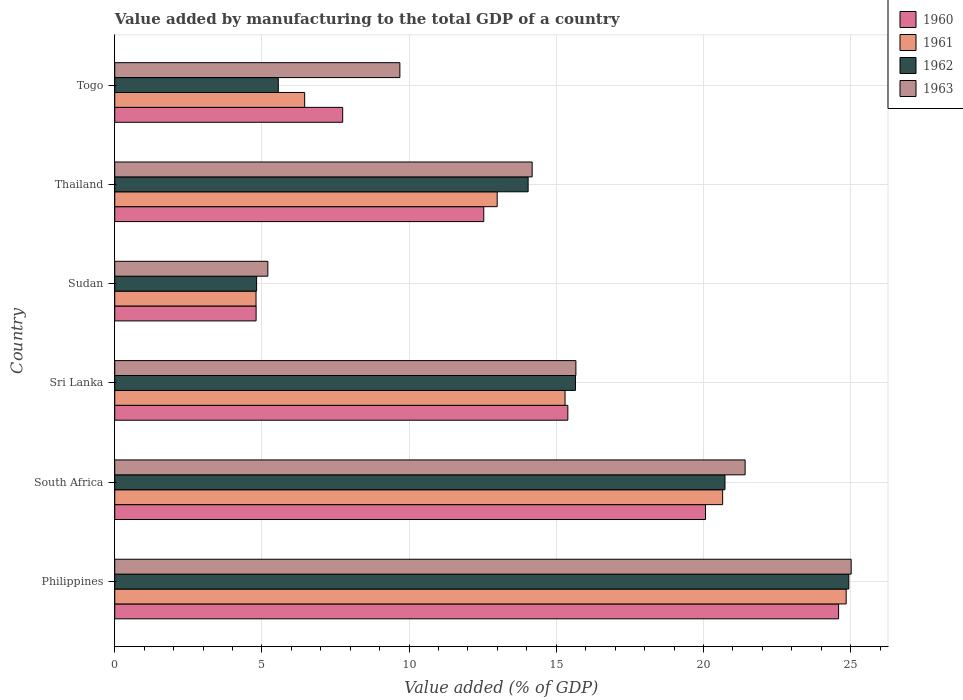How many groups of bars are there?
Provide a succinct answer. 6. How many bars are there on the 1st tick from the bottom?
Your response must be concise. 4. What is the label of the 1st group of bars from the top?
Keep it short and to the point. Togo. In how many cases, is the number of bars for a given country not equal to the number of legend labels?
Your answer should be very brief. 0. What is the value added by manufacturing to the total GDP in 1962 in Philippines?
Your answer should be compact. 24.94. Across all countries, what is the maximum value added by manufacturing to the total GDP in 1962?
Keep it short and to the point. 24.94. Across all countries, what is the minimum value added by manufacturing to the total GDP in 1963?
Ensure brevity in your answer.  5.2. In which country was the value added by manufacturing to the total GDP in 1963 maximum?
Offer a very short reply. Philippines. In which country was the value added by manufacturing to the total GDP in 1960 minimum?
Make the answer very short. Sudan. What is the total value added by manufacturing to the total GDP in 1960 in the graph?
Provide a succinct answer. 85.14. What is the difference between the value added by manufacturing to the total GDP in 1963 in Philippines and that in Sudan?
Your answer should be very brief. 19.82. What is the difference between the value added by manufacturing to the total GDP in 1962 in Togo and the value added by manufacturing to the total GDP in 1960 in Thailand?
Your response must be concise. -6.98. What is the average value added by manufacturing to the total GDP in 1961 per country?
Provide a short and direct response. 14.17. What is the difference between the value added by manufacturing to the total GDP in 1960 and value added by manufacturing to the total GDP in 1961 in South Africa?
Your answer should be compact. -0.58. What is the ratio of the value added by manufacturing to the total GDP in 1960 in Philippines to that in Sri Lanka?
Offer a very short reply. 1.6. What is the difference between the highest and the second highest value added by manufacturing to the total GDP in 1962?
Keep it short and to the point. 4.21. What is the difference between the highest and the lowest value added by manufacturing to the total GDP in 1963?
Make the answer very short. 19.82. Is the sum of the value added by manufacturing to the total GDP in 1960 in Philippines and Sudan greater than the maximum value added by manufacturing to the total GDP in 1962 across all countries?
Your answer should be very brief. Yes. What does the 1st bar from the top in Sri Lanka represents?
Provide a succinct answer. 1963. Is it the case that in every country, the sum of the value added by manufacturing to the total GDP in 1962 and value added by manufacturing to the total GDP in 1963 is greater than the value added by manufacturing to the total GDP in 1961?
Offer a terse response. Yes. How many bars are there?
Offer a terse response. 24. Are all the bars in the graph horizontal?
Provide a short and direct response. Yes. How many countries are there in the graph?
Provide a succinct answer. 6. Are the values on the major ticks of X-axis written in scientific E-notation?
Keep it short and to the point. No. Where does the legend appear in the graph?
Keep it short and to the point. Top right. How many legend labels are there?
Your answer should be compact. 4. What is the title of the graph?
Your answer should be compact. Value added by manufacturing to the total GDP of a country. Does "2013" appear as one of the legend labels in the graph?
Make the answer very short. No. What is the label or title of the X-axis?
Offer a terse response. Value added (% of GDP). What is the Value added (% of GDP) in 1960 in Philippines?
Your answer should be very brief. 24.59. What is the Value added (% of GDP) in 1961 in Philippines?
Offer a terse response. 24.85. What is the Value added (% of GDP) of 1962 in Philippines?
Provide a short and direct response. 24.94. What is the Value added (% of GDP) of 1963 in Philippines?
Provide a short and direct response. 25.02. What is the Value added (% of GDP) in 1960 in South Africa?
Offer a terse response. 20.07. What is the Value added (% of GDP) of 1961 in South Africa?
Offer a very short reply. 20.65. What is the Value added (% of GDP) in 1962 in South Africa?
Ensure brevity in your answer.  20.73. What is the Value added (% of GDP) in 1963 in South Africa?
Offer a terse response. 21.42. What is the Value added (% of GDP) of 1960 in Sri Lanka?
Give a very brief answer. 15.39. What is the Value added (% of GDP) in 1961 in Sri Lanka?
Your answer should be very brief. 15.3. What is the Value added (% of GDP) in 1962 in Sri Lanka?
Provide a succinct answer. 15.65. What is the Value added (% of GDP) in 1963 in Sri Lanka?
Provide a succinct answer. 15.67. What is the Value added (% of GDP) of 1960 in Sudan?
Provide a succinct answer. 4.8. What is the Value added (% of GDP) in 1961 in Sudan?
Give a very brief answer. 4.8. What is the Value added (% of GDP) of 1962 in Sudan?
Provide a succinct answer. 4.82. What is the Value added (% of GDP) in 1963 in Sudan?
Make the answer very short. 5.2. What is the Value added (% of GDP) of 1960 in Thailand?
Offer a terse response. 12.54. What is the Value added (% of GDP) in 1961 in Thailand?
Your answer should be very brief. 12.99. What is the Value added (% of GDP) of 1962 in Thailand?
Ensure brevity in your answer.  14.04. What is the Value added (% of GDP) in 1963 in Thailand?
Provide a short and direct response. 14.18. What is the Value added (% of GDP) of 1960 in Togo?
Offer a terse response. 7.74. What is the Value added (% of GDP) of 1961 in Togo?
Give a very brief answer. 6.45. What is the Value added (% of GDP) of 1962 in Togo?
Make the answer very short. 5.56. What is the Value added (% of GDP) of 1963 in Togo?
Offer a very short reply. 9.69. Across all countries, what is the maximum Value added (% of GDP) in 1960?
Provide a short and direct response. 24.59. Across all countries, what is the maximum Value added (% of GDP) in 1961?
Provide a short and direct response. 24.85. Across all countries, what is the maximum Value added (% of GDP) of 1962?
Ensure brevity in your answer.  24.94. Across all countries, what is the maximum Value added (% of GDP) of 1963?
Offer a very short reply. 25.02. Across all countries, what is the minimum Value added (% of GDP) of 1960?
Provide a succinct answer. 4.8. Across all countries, what is the minimum Value added (% of GDP) of 1961?
Offer a very short reply. 4.8. Across all countries, what is the minimum Value added (% of GDP) in 1962?
Provide a succinct answer. 4.82. Across all countries, what is the minimum Value added (% of GDP) in 1963?
Your response must be concise. 5.2. What is the total Value added (% of GDP) of 1960 in the graph?
Provide a succinct answer. 85.14. What is the total Value added (% of GDP) of 1961 in the graph?
Your answer should be compact. 85.04. What is the total Value added (% of GDP) in 1962 in the graph?
Your answer should be compact. 85.74. What is the total Value added (% of GDP) of 1963 in the graph?
Offer a very short reply. 91.17. What is the difference between the Value added (% of GDP) in 1960 in Philippines and that in South Africa?
Provide a short and direct response. 4.52. What is the difference between the Value added (% of GDP) of 1961 in Philippines and that in South Africa?
Provide a succinct answer. 4.2. What is the difference between the Value added (% of GDP) in 1962 in Philippines and that in South Africa?
Ensure brevity in your answer.  4.21. What is the difference between the Value added (% of GDP) of 1963 in Philippines and that in South Africa?
Your answer should be compact. 3.6. What is the difference between the Value added (% of GDP) in 1960 in Philippines and that in Sri Lanka?
Provide a succinct answer. 9.2. What is the difference between the Value added (% of GDP) of 1961 in Philippines and that in Sri Lanka?
Your answer should be compact. 9.55. What is the difference between the Value added (% of GDP) of 1962 in Philippines and that in Sri Lanka?
Keep it short and to the point. 9.29. What is the difference between the Value added (% of GDP) of 1963 in Philippines and that in Sri Lanka?
Offer a terse response. 9.35. What is the difference between the Value added (% of GDP) of 1960 in Philippines and that in Sudan?
Your answer should be very brief. 19.79. What is the difference between the Value added (% of GDP) of 1961 in Philippines and that in Sudan?
Make the answer very short. 20.05. What is the difference between the Value added (% of GDP) in 1962 in Philippines and that in Sudan?
Make the answer very short. 20.12. What is the difference between the Value added (% of GDP) in 1963 in Philippines and that in Sudan?
Provide a short and direct response. 19.82. What is the difference between the Value added (% of GDP) of 1960 in Philippines and that in Thailand?
Keep it short and to the point. 12.05. What is the difference between the Value added (% of GDP) in 1961 in Philippines and that in Thailand?
Your answer should be very brief. 11.86. What is the difference between the Value added (% of GDP) in 1962 in Philippines and that in Thailand?
Offer a terse response. 10.9. What is the difference between the Value added (% of GDP) in 1963 in Philippines and that in Thailand?
Your response must be concise. 10.84. What is the difference between the Value added (% of GDP) of 1960 in Philippines and that in Togo?
Offer a terse response. 16.85. What is the difference between the Value added (% of GDP) of 1961 in Philippines and that in Togo?
Ensure brevity in your answer.  18.4. What is the difference between the Value added (% of GDP) of 1962 in Philippines and that in Togo?
Make the answer very short. 19.38. What is the difference between the Value added (% of GDP) in 1963 in Philippines and that in Togo?
Make the answer very short. 15.33. What is the difference between the Value added (% of GDP) of 1960 in South Africa and that in Sri Lanka?
Your response must be concise. 4.68. What is the difference between the Value added (% of GDP) of 1961 in South Africa and that in Sri Lanka?
Offer a terse response. 5.36. What is the difference between the Value added (% of GDP) in 1962 in South Africa and that in Sri Lanka?
Offer a terse response. 5.08. What is the difference between the Value added (% of GDP) of 1963 in South Africa and that in Sri Lanka?
Offer a terse response. 5.75. What is the difference between the Value added (% of GDP) in 1960 in South Africa and that in Sudan?
Make the answer very short. 15.27. What is the difference between the Value added (% of GDP) of 1961 in South Africa and that in Sudan?
Your answer should be very brief. 15.85. What is the difference between the Value added (% of GDP) of 1962 in South Africa and that in Sudan?
Provide a short and direct response. 15.91. What is the difference between the Value added (% of GDP) in 1963 in South Africa and that in Sudan?
Provide a short and direct response. 16.22. What is the difference between the Value added (% of GDP) of 1960 in South Africa and that in Thailand?
Provide a short and direct response. 7.53. What is the difference between the Value added (% of GDP) of 1961 in South Africa and that in Thailand?
Offer a very short reply. 7.66. What is the difference between the Value added (% of GDP) of 1962 in South Africa and that in Thailand?
Keep it short and to the point. 6.69. What is the difference between the Value added (% of GDP) of 1963 in South Africa and that in Thailand?
Ensure brevity in your answer.  7.24. What is the difference between the Value added (% of GDP) of 1960 in South Africa and that in Togo?
Offer a terse response. 12.33. What is the difference between the Value added (% of GDP) in 1961 in South Africa and that in Togo?
Offer a very short reply. 14.2. What is the difference between the Value added (% of GDP) of 1962 in South Africa and that in Togo?
Provide a short and direct response. 15.18. What is the difference between the Value added (% of GDP) in 1963 in South Africa and that in Togo?
Provide a short and direct response. 11.73. What is the difference between the Value added (% of GDP) of 1960 in Sri Lanka and that in Sudan?
Make the answer very short. 10.59. What is the difference between the Value added (% of GDP) in 1961 in Sri Lanka and that in Sudan?
Make the answer very short. 10.5. What is the difference between the Value added (% of GDP) of 1962 in Sri Lanka and that in Sudan?
Give a very brief answer. 10.83. What is the difference between the Value added (% of GDP) in 1963 in Sri Lanka and that in Sudan?
Your answer should be very brief. 10.47. What is the difference between the Value added (% of GDP) of 1960 in Sri Lanka and that in Thailand?
Provide a short and direct response. 2.86. What is the difference between the Value added (% of GDP) in 1961 in Sri Lanka and that in Thailand?
Your response must be concise. 2.3. What is the difference between the Value added (% of GDP) of 1962 in Sri Lanka and that in Thailand?
Keep it short and to the point. 1.61. What is the difference between the Value added (% of GDP) in 1963 in Sri Lanka and that in Thailand?
Provide a short and direct response. 1.49. What is the difference between the Value added (% of GDP) in 1960 in Sri Lanka and that in Togo?
Offer a very short reply. 7.65. What is the difference between the Value added (% of GDP) of 1961 in Sri Lanka and that in Togo?
Offer a terse response. 8.85. What is the difference between the Value added (% of GDP) of 1962 in Sri Lanka and that in Togo?
Provide a succinct answer. 10.1. What is the difference between the Value added (% of GDP) in 1963 in Sri Lanka and that in Togo?
Ensure brevity in your answer.  5.98. What is the difference between the Value added (% of GDP) of 1960 in Sudan and that in Thailand?
Make the answer very short. -7.73. What is the difference between the Value added (% of GDP) in 1961 in Sudan and that in Thailand?
Ensure brevity in your answer.  -8.19. What is the difference between the Value added (% of GDP) of 1962 in Sudan and that in Thailand?
Offer a terse response. -9.23. What is the difference between the Value added (% of GDP) in 1963 in Sudan and that in Thailand?
Offer a terse response. -8.98. What is the difference between the Value added (% of GDP) in 1960 in Sudan and that in Togo?
Provide a succinct answer. -2.94. What is the difference between the Value added (% of GDP) of 1961 in Sudan and that in Togo?
Your answer should be very brief. -1.65. What is the difference between the Value added (% of GDP) in 1962 in Sudan and that in Togo?
Your answer should be very brief. -0.74. What is the difference between the Value added (% of GDP) in 1963 in Sudan and that in Togo?
Provide a succinct answer. -4.49. What is the difference between the Value added (% of GDP) of 1960 in Thailand and that in Togo?
Your answer should be very brief. 4.79. What is the difference between the Value added (% of GDP) of 1961 in Thailand and that in Togo?
Offer a terse response. 6.54. What is the difference between the Value added (% of GDP) in 1962 in Thailand and that in Togo?
Offer a very short reply. 8.49. What is the difference between the Value added (% of GDP) of 1963 in Thailand and that in Togo?
Offer a very short reply. 4.49. What is the difference between the Value added (% of GDP) in 1960 in Philippines and the Value added (% of GDP) in 1961 in South Africa?
Your response must be concise. 3.94. What is the difference between the Value added (% of GDP) of 1960 in Philippines and the Value added (% of GDP) of 1962 in South Africa?
Ensure brevity in your answer.  3.86. What is the difference between the Value added (% of GDP) of 1960 in Philippines and the Value added (% of GDP) of 1963 in South Africa?
Offer a terse response. 3.18. What is the difference between the Value added (% of GDP) in 1961 in Philippines and the Value added (% of GDP) in 1962 in South Africa?
Offer a terse response. 4.12. What is the difference between the Value added (% of GDP) of 1961 in Philippines and the Value added (% of GDP) of 1963 in South Africa?
Provide a short and direct response. 3.43. What is the difference between the Value added (% of GDP) of 1962 in Philippines and the Value added (% of GDP) of 1963 in South Africa?
Your response must be concise. 3.52. What is the difference between the Value added (% of GDP) in 1960 in Philippines and the Value added (% of GDP) in 1961 in Sri Lanka?
Ensure brevity in your answer.  9.29. What is the difference between the Value added (% of GDP) of 1960 in Philippines and the Value added (% of GDP) of 1962 in Sri Lanka?
Your response must be concise. 8.94. What is the difference between the Value added (% of GDP) in 1960 in Philippines and the Value added (% of GDP) in 1963 in Sri Lanka?
Offer a very short reply. 8.93. What is the difference between the Value added (% of GDP) in 1961 in Philippines and the Value added (% of GDP) in 1962 in Sri Lanka?
Provide a succinct answer. 9.2. What is the difference between the Value added (% of GDP) of 1961 in Philippines and the Value added (% of GDP) of 1963 in Sri Lanka?
Offer a terse response. 9.18. What is the difference between the Value added (% of GDP) of 1962 in Philippines and the Value added (% of GDP) of 1963 in Sri Lanka?
Ensure brevity in your answer.  9.27. What is the difference between the Value added (% of GDP) in 1960 in Philippines and the Value added (% of GDP) in 1961 in Sudan?
Make the answer very short. 19.79. What is the difference between the Value added (% of GDP) in 1960 in Philippines and the Value added (% of GDP) in 1962 in Sudan?
Offer a very short reply. 19.77. What is the difference between the Value added (% of GDP) of 1960 in Philippines and the Value added (% of GDP) of 1963 in Sudan?
Give a very brief answer. 19.39. What is the difference between the Value added (% of GDP) in 1961 in Philippines and the Value added (% of GDP) in 1962 in Sudan?
Ensure brevity in your answer.  20.03. What is the difference between the Value added (% of GDP) of 1961 in Philippines and the Value added (% of GDP) of 1963 in Sudan?
Your answer should be compact. 19.65. What is the difference between the Value added (% of GDP) of 1962 in Philippines and the Value added (% of GDP) of 1963 in Sudan?
Keep it short and to the point. 19.74. What is the difference between the Value added (% of GDP) in 1960 in Philippines and the Value added (% of GDP) in 1961 in Thailand?
Offer a terse response. 11.6. What is the difference between the Value added (% of GDP) in 1960 in Philippines and the Value added (% of GDP) in 1962 in Thailand?
Ensure brevity in your answer.  10.55. What is the difference between the Value added (% of GDP) of 1960 in Philippines and the Value added (% of GDP) of 1963 in Thailand?
Make the answer very short. 10.41. What is the difference between the Value added (% of GDP) in 1961 in Philippines and the Value added (% of GDP) in 1962 in Thailand?
Give a very brief answer. 10.81. What is the difference between the Value added (% of GDP) in 1961 in Philippines and the Value added (% of GDP) in 1963 in Thailand?
Your answer should be compact. 10.67. What is the difference between the Value added (% of GDP) in 1962 in Philippines and the Value added (% of GDP) in 1963 in Thailand?
Offer a very short reply. 10.76. What is the difference between the Value added (% of GDP) in 1960 in Philippines and the Value added (% of GDP) in 1961 in Togo?
Your answer should be compact. 18.14. What is the difference between the Value added (% of GDP) in 1960 in Philippines and the Value added (% of GDP) in 1962 in Togo?
Provide a short and direct response. 19.04. What is the difference between the Value added (% of GDP) of 1960 in Philippines and the Value added (% of GDP) of 1963 in Togo?
Provide a short and direct response. 14.91. What is the difference between the Value added (% of GDP) of 1961 in Philippines and the Value added (% of GDP) of 1962 in Togo?
Make the answer very short. 19.29. What is the difference between the Value added (% of GDP) in 1961 in Philippines and the Value added (% of GDP) in 1963 in Togo?
Give a very brief answer. 15.16. What is the difference between the Value added (% of GDP) of 1962 in Philippines and the Value added (% of GDP) of 1963 in Togo?
Offer a very short reply. 15.25. What is the difference between the Value added (% of GDP) in 1960 in South Africa and the Value added (% of GDP) in 1961 in Sri Lanka?
Your answer should be compact. 4.77. What is the difference between the Value added (% of GDP) of 1960 in South Africa and the Value added (% of GDP) of 1962 in Sri Lanka?
Offer a very short reply. 4.42. What is the difference between the Value added (% of GDP) of 1960 in South Africa and the Value added (% of GDP) of 1963 in Sri Lanka?
Give a very brief answer. 4.4. What is the difference between the Value added (% of GDP) in 1961 in South Africa and the Value added (% of GDP) in 1962 in Sri Lanka?
Make the answer very short. 5. What is the difference between the Value added (% of GDP) of 1961 in South Africa and the Value added (% of GDP) of 1963 in Sri Lanka?
Offer a terse response. 4.99. What is the difference between the Value added (% of GDP) of 1962 in South Africa and the Value added (% of GDP) of 1963 in Sri Lanka?
Your answer should be very brief. 5.07. What is the difference between the Value added (% of GDP) in 1960 in South Africa and the Value added (% of GDP) in 1961 in Sudan?
Give a very brief answer. 15.27. What is the difference between the Value added (% of GDP) in 1960 in South Africa and the Value added (% of GDP) in 1962 in Sudan?
Keep it short and to the point. 15.25. What is the difference between the Value added (% of GDP) of 1960 in South Africa and the Value added (% of GDP) of 1963 in Sudan?
Your answer should be very brief. 14.87. What is the difference between the Value added (% of GDP) in 1961 in South Africa and the Value added (% of GDP) in 1962 in Sudan?
Provide a succinct answer. 15.83. What is the difference between the Value added (% of GDP) of 1961 in South Africa and the Value added (% of GDP) of 1963 in Sudan?
Provide a short and direct response. 15.45. What is the difference between the Value added (% of GDP) in 1962 in South Africa and the Value added (% of GDP) in 1963 in Sudan?
Provide a succinct answer. 15.53. What is the difference between the Value added (% of GDP) in 1960 in South Africa and the Value added (% of GDP) in 1961 in Thailand?
Ensure brevity in your answer.  7.08. What is the difference between the Value added (% of GDP) in 1960 in South Africa and the Value added (% of GDP) in 1962 in Thailand?
Provide a short and direct response. 6.03. What is the difference between the Value added (% of GDP) in 1960 in South Africa and the Value added (% of GDP) in 1963 in Thailand?
Ensure brevity in your answer.  5.89. What is the difference between the Value added (% of GDP) in 1961 in South Africa and the Value added (% of GDP) in 1962 in Thailand?
Your response must be concise. 6.61. What is the difference between the Value added (% of GDP) in 1961 in South Africa and the Value added (% of GDP) in 1963 in Thailand?
Offer a terse response. 6.47. What is the difference between the Value added (% of GDP) in 1962 in South Africa and the Value added (% of GDP) in 1963 in Thailand?
Ensure brevity in your answer.  6.55. What is the difference between the Value added (% of GDP) of 1960 in South Africa and the Value added (% of GDP) of 1961 in Togo?
Offer a very short reply. 13.62. What is the difference between the Value added (% of GDP) in 1960 in South Africa and the Value added (% of GDP) in 1962 in Togo?
Your answer should be compact. 14.51. What is the difference between the Value added (% of GDP) in 1960 in South Africa and the Value added (% of GDP) in 1963 in Togo?
Provide a short and direct response. 10.38. What is the difference between the Value added (% of GDP) of 1961 in South Africa and the Value added (% of GDP) of 1962 in Togo?
Offer a terse response. 15.1. What is the difference between the Value added (% of GDP) of 1961 in South Africa and the Value added (% of GDP) of 1963 in Togo?
Make the answer very short. 10.97. What is the difference between the Value added (% of GDP) in 1962 in South Africa and the Value added (% of GDP) in 1963 in Togo?
Offer a terse response. 11.05. What is the difference between the Value added (% of GDP) in 1960 in Sri Lanka and the Value added (% of GDP) in 1961 in Sudan?
Keep it short and to the point. 10.59. What is the difference between the Value added (% of GDP) in 1960 in Sri Lanka and the Value added (% of GDP) in 1962 in Sudan?
Provide a short and direct response. 10.57. What is the difference between the Value added (% of GDP) of 1960 in Sri Lanka and the Value added (% of GDP) of 1963 in Sudan?
Your answer should be compact. 10.19. What is the difference between the Value added (% of GDP) in 1961 in Sri Lanka and the Value added (% of GDP) in 1962 in Sudan?
Provide a short and direct response. 10.48. What is the difference between the Value added (% of GDP) in 1961 in Sri Lanka and the Value added (% of GDP) in 1963 in Sudan?
Provide a short and direct response. 10.1. What is the difference between the Value added (% of GDP) of 1962 in Sri Lanka and the Value added (% of GDP) of 1963 in Sudan?
Provide a short and direct response. 10.45. What is the difference between the Value added (% of GDP) in 1960 in Sri Lanka and the Value added (% of GDP) in 1961 in Thailand?
Your answer should be compact. 2.4. What is the difference between the Value added (% of GDP) in 1960 in Sri Lanka and the Value added (% of GDP) in 1962 in Thailand?
Ensure brevity in your answer.  1.35. What is the difference between the Value added (% of GDP) of 1960 in Sri Lanka and the Value added (% of GDP) of 1963 in Thailand?
Ensure brevity in your answer.  1.21. What is the difference between the Value added (% of GDP) of 1961 in Sri Lanka and the Value added (% of GDP) of 1962 in Thailand?
Give a very brief answer. 1.25. What is the difference between the Value added (% of GDP) of 1961 in Sri Lanka and the Value added (% of GDP) of 1963 in Thailand?
Your response must be concise. 1.12. What is the difference between the Value added (% of GDP) of 1962 in Sri Lanka and the Value added (% of GDP) of 1963 in Thailand?
Provide a succinct answer. 1.47. What is the difference between the Value added (% of GDP) in 1960 in Sri Lanka and the Value added (% of GDP) in 1961 in Togo?
Your response must be concise. 8.94. What is the difference between the Value added (% of GDP) of 1960 in Sri Lanka and the Value added (% of GDP) of 1962 in Togo?
Your response must be concise. 9.84. What is the difference between the Value added (% of GDP) in 1960 in Sri Lanka and the Value added (% of GDP) in 1963 in Togo?
Your answer should be very brief. 5.71. What is the difference between the Value added (% of GDP) in 1961 in Sri Lanka and the Value added (% of GDP) in 1962 in Togo?
Your response must be concise. 9.74. What is the difference between the Value added (% of GDP) in 1961 in Sri Lanka and the Value added (% of GDP) in 1963 in Togo?
Your response must be concise. 5.61. What is the difference between the Value added (% of GDP) in 1962 in Sri Lanka and the Value added (% of GDP) in 1963 in Togo?
Keep it short and to the point. 5.97. What is the difference between the Value added (% of GDP) of 1960 in Sudan and the Value added (% of GDP) of 1961 in Thailand?
Offer a very short reply. -8.19. What is the difference between the Value added (% of GDP) in 1960 in Sudan and the Value added (% of GDP) in 1962 in Thailand?
Keep it short and to the point. -9.24. What is the difference between the Value added (% of GDP) of 1960 in Sudan and the Value added (% of GDP) of 1963 in Thailand?
Your answer should be compact. -9.38. What is the difference between the Value added (% of GDP) of 1961 in Sudan and the Value added (% of GDP) of 1962 in Thailand?
Keep it short and to the point. -9.24. What is the difference between the Value added (% of GDP) of 1961 in Sudan and the Value added (% of GDP) of 1963 in Thailand?
Provide a succinct answer. -9.38. What is the difference between the Value added (% of GDP) of 1962 in Sudan and the Value added (% of GDP) of 1963 in Thailand?
Keep it short and to the point. -9.36. What is the difference between the Value added (% of GDP) of 1960 in Sudan and the Value added (% of GDP) of 1961 in Togo?
Offer a very short reply. -1.65. What is the difference between the Value added (% of GDP) in 1960 in Sudan and the Value added (% of GDP) in 1962 in Togo?
Keep it short and to the point. -0.75. What is the difference between the Value added (% of GDP) of 1960 in Sudan and the Value added (% of GDP) of 1963 in Togo?
Provide a short and direct response. -4.88. What is the difference between the Value added (% of GDP) of 1961 in Sudan and the Value added (% of GDP) of 1962 in Togo?
Provide a succinct answer. -0.76. What is the difference between the Value added (% of GDP) of 1961 in Sudan and the Value added (% of GDP) of 1963 in Togo?
Make the answer very short. -4.89. What is the difference between the Value added (% of GDP) of 1962 in Sudan and the Value added (% of GDP) of 1963 in Togo?
Your response must be concise. -4.87. What is the difference between the Value added (% of GDP) of 1960 in Thailand and the Value added (% of GDP) of 1961 in Togo?
Offer a very short reply. 6.09. What is the difference between the Value added (% of GDP) in 1960 in Thailand and the Value added (% of GDP) in 1962 in Togo?
Offer a terse response. 6.98. What is the difference between the Value added (% of GDP) of 1960 in Thailand and the Value added (% of GDP) of 1963 in Togo?
Your answer should be compact. 2.85. What is the difference between the Value added (% of GDP) in 1961 in Thailand and the Value added (% of GDP) in 1962 in Togo?
Provide a short and direct response. 7.44. What is the difference between the Value added (% of GDP) of 1961 in Thailand and the Value added (% of GDP) of 1963 in Togo?
Offer a terse response. 3.31. What is the difference between the Value added (% of GDP) of 1962 in Thailand and the Value added (% of GDP) of 1963 in Togo?
Give a very brief answer. 4.36. What is the average Value added (% of GDP) of 1960 per country?
Give a very brief answer. 14.19. What is the average Value added (% of GDP) of 1961 per country?
Offer a very short reply. 14.17. What is the average Value added (% of GDP) in 1962 per country?
Offer a terse response. 14.29. What is the average Value added (% of GDP) of 1963 per country?
Offer a terse response. 15.2. What is the difference between the Value added (% of GDP) of 1960 and Value added (% of GDP) of 1961 in Philippines?
Your response must be concise. -0.26. What is the difference between the Value added (% of GDP) of 1960 and Value added (% of GDP) of 1962 in Philippines?
Your answer should be compact. -0.35. What is the difference between the Value added (% of GDP) in 1960 and Value added (% of GDP) in 1963 in Philippines?
Keep it short and to the point. -0.43. What is the difference between the Value added (% of GDP) of 1961 and Value added (% of GDP) of 1962 in Philippines?
Offer a terse response. -0.09. What is the difference between the Value added (% of GDP) of 1961 and Value added (% of GDP) of 1963 in Philippines?
Your answer should be very brief. -0.17. What is the difference between the Value added (% of GDP) of 1962 and Value added (% of GDP) of 1963 in Philippines?
Your answer should be very brief. -0.08. What is the difference between the Value added (% of GDP) in 1960 and Value added (% of GDP) in 1961 in South Africa?
Provide a short and direct response. -0.58. What is the difference between the Value added (% of GDP) of 1960 and Value added (% of GDP) of 1962 in South Africa?
Your answer should be compact. -0.66. What is the difference between the Value added (% of GDP) of 1960 and Value added (% of GDP) of 1963 in South Africa?
Offer a terse response. -1.35. What is the difference between the Value added (% of GDP) of 1961 and Value added (% of GDP) of 1962 in South Africa?
Make the answer very short. -0.08. What is the difference between the Value added (% of GDP) in 1961 and Value added (% of GDP) in 1963 in South Africa?
Ensure brevity in your answer.  -0.76. What is the difference between the Value added (% of GDP) in 1962 and Value added (% of GDP) in 1963 in South Africa?
Offer a very short reply. -0.68. What is the difference between the Value added (% of GDP) of 1960 and Value added (% of GDP) of 1961 in Sri Lanka?
Your response must be concise. 0.1. What is the difference between the Value added (% of GDP) in 1960 and Value added (% of GDP) in 1962 in Sri Lanka?
Your answer should be compact. -0.26. What is the difference between the Value added (% of GDP) of 1960 and Value added (% of GDP) of 1963 in Sri Lanka?
Provide a succinct answer. -0.27. What is the difference between the Value added (% of GDP) of 1961 and Value added (% of GDP) of 1962 in Sri Lanka?
Your response must be concise. -0.35. What is the difference between the Value added (% of GDP) in 1961 and Value added (% of GDP) in 1963 in Sri Lanka?
Offer a terse response. -0.37. What is the difference between the Value added (% of GDP) in 1962 and Value added (% of GDP) in 1963 in Sri Lanka?
Provide a succinct answer. -0.01. What is the difference between the Value added (% of GDP) in 1960 and Value added (% of GDP) in 1961 in Sudan?
Offer a terse response. 0. What is the difference between the Value added (% of GDP) in 1960 and Value added (% of GDP) in 1962 in Sudan?
Ensure brevity in your answer.  -0.02. What is the difference between the Value added (% of GDP) in 1960 and Value added (% of GDP) in 1963 in Sudan?
Give a very brief answer. -0.4. What is the difference between the Value added (% of GDP) in 1961 and Value added (% of GDP) in 1962 in Sudan?
Your response must be concise. -0.02. What is the difference between the Value added (% of GDP) in 1961 and Value added (% of GDP) in 1963 in Sudan?
Ensure brevity in your answer.  -0.4. What is the difference between the Value added (% of GDP) in 1962 and Value added (% of GDP) in 1963 in Sudan?
Provide a short and direct response. -0.38. What is the difference between the Value added (% of GDP) of 1960 and Value added (% of GDP) of 1961 in Thailand?
Provide a short and direct response. -0.46. What is the difference between the Value added (% of GDP) in 1960 and Value added (% of GDP) in 1962 in Thailand?
Provide a succinct answer. -1.51. What is the difference between the Value added (% of GDP) in 1960 and Value added (% of GDP) in 1963 in Thailand?
Your answer should be very brief. -1.64. What is the difference between the Value added (% of GDP) in 1961 and Value added (% of GDP) in 1962 in Thailand?
Your answer should be very brief. -1.05. What is the difference between the Value added (% of GDP) of 1961 and Value added (% of GDP) of 1963 in Thailand?
Your response must be concise. -1.19. What is the difference between the Value added (% of GDP) in 1962 and Value added (% of GDP) in 1963 in Thailand?
Ensure brevity in your answer.  -0.14. What is the difference between the Value added (% of GDP) in 1960 and Value added (% of GDP) in 1961 in Togo?
Your response must be concise. 1.29. What is the difference between the Value added (% of GDP) of 1960 and Value added (% of GDP) of 1962 in Togo?
Your response must be concise. 2.19. What is the difference between the Value added (% of GDP) of 1960 and Value added (% of GDP) of 1963 in Togo?
Offer a terse response. -1.94. What is the difference between the Value added (% of GDP) in 1961 and Value added (% of GDP) in 1962 in Togo?
Your answer should be very brief. 0.9. What is the difference between the Value added (% of GDP) in 1961 and Value added (% of GDP) in 1963 in Togo?
Your answer should be compact. -3.23. What is the difference between the Value added (% of GDP) of 1962 and Value added (% of GDP) of 1963 in Togo?
Provide a succinct answer. -4.13. What is the ratio of the Value added (% of GDP) in 1960 in Philippines to that in South Africa?
Ensure brevity in your answer.  1.23. What is the ratio of the Value added (% of GDP) in 1961 in Philippines to that in South Africa?
Keep it short and to the point. 1.2. What is the ratio of the Value added (% of GDP) in 1962 in Philippines to that in South Africa?
Keep it short and to the point. 1.2. What is the ratio of the Value added (% of GDP) in 1963 in Philippines to that in South Africa?
Provide a short and direct response. 1.17. What is the ratio of the Value added (% of GDP) in 1960 in Philippines to that in Sri Lanka?
Your response must be concise. 1.6. What is the ratio of the Value added (% of GDP) in 1961 in Philippines to that in Sri Lanka?
Your answer should be very brief. 1.62. What is the ratio of the Value added (% of GDP) in 1962 in Philippines to that in Sri Lanka?
Make the answer very short. 1.59. What is the ratio of the Value added (% of GDP) in 1963 in Philippines to that in Sri Lanka?
Offer a terse response. 1.6. What is the ratio of the Value added (% of GDP) of 1960 in Philippines to that in Sudan?
Your answer should be compact. 5.12. What is the ratio of the Value added (% of GDP) in 1961 in Philippines to that in Sudan?
Offer a very short reply. 5.18. What is the ratio of the Value added (% of GDP) in 1962 in Philippines to that in Sudan?
Your response must be concise. 5.18. What is the ratio of the Value added (% of GDP) in 1963 in Philippines to that in Sudan?
Offer a very short reply. 4.81. What is the ratio of the Value added (% of GDP) of 1960 in Philippines to that in Thailand?
Provide a succinct answer. 1.96. What is the ratio of the Value added (% of GDP) of 1961 in Philippines to that in Thailand?
Offer a terse response. 1.91. What is the ratio of the Value added (% of GDP) in 1962 in Philippines to that in Thailand?
Your answer should be very brief. 1.78. What is the ratio of the Value added (% of GDP) in 1963 in Philippines to that in Thailand?
Offer a terse response. 1.76. What is the ratio of the Value added (% of GDP) in 1960 in Philippines to that in Togo?
Ensure brevity in your answer.  3.18. What is the ratio of the Value added (% of GDP) in 1961 in Philippines to that in Togo?
Your response must be concise. 3.85. What is the ratio of the Value added (% of GDP) in 1962 in Philippines to that in Togo?
Give a very brief answer. 4.49. What is the ratio of the Value added (% of GDP) of 1963 in Philippines to that in Togo?
Your answer should be compact. 2.58. What is the ratio of the Value added (% of GDP) of 1960 in South Africa to that in Sri Lanka?
Make the answer very short. 1.3. What is the ratio of the Value added (% of GDP) of 1961 in South Africa to that in Sri Lanka?
Provide a short and direct response. 1.35. What is the ratio of the Value added (% of GDP) in 1962 in South Africa to that in Sri Lanka?
Your response must be concise. 1.32. What is the ratio of the Value added (% of GDP) in 1963 in South Africa to that in Sri Lanka?
Your answer should be compact. 1.37. What is the ratio of the Value added (% of GDP) in 1960 in South Africa to that in Sudan?
Your answer should be very brief. 4.18. What is the ratio of the Value added (% of GDP) in 1961 in South Africa to that in Sudan?
Give a very brief answer. 4.3. What is the ratio of the Value added (% of GDP) in 1962 in South Africa to that in Sudan?
Keep it short and to the point. 4.3. What is the ratio of the Value added (% of GDP) of 1963 in South Africa to that in Sudan?
Offer a very short reply. 4.12. What is the ratio of the Value added (% of GDP) in 1960 in South Africa to that in Thailand?
Offer a terse response. 1.6. What is the ratio of the Value added (% of GDP) of 1961 in South Africa to that in Thailand?
Your response must be concise. 1.59. What is the ratio of the Value added (% of GDP) of 1962 in South Africa to that in Thailand?
Your response must be concise. 1.48. What is the ratio of the Value added (% of GDP) of 1963 in South Africa to that in Thailand?
Your response must be concise. 1.51. What is the ratio of the Value added (% of GDP) in 1960 in South Africa to that in Togo?
Make the answer very short. 2.59. What is the ratio of the Value added (% of GDP) of 1961 in South Africa to that in Togo?
Your answer should be compact. 3.2. What is the ratio of the Value added (% of GDP) of 1962 in South Africa to that in Togo?
Offer a terse response. 3.73. What is the ratio of the Value added (% of GDP) of 1963 in South Africa to that in Togo?
Give a very brief answer. 2.21. What is the ratio of the Value added (% of GDP) of 1960 in Sri Lanka to that in Sudan?
Provide a short and direct response. 3.21. What is the ratio of the Value added (% of GDP) in 1961 in Sri Lanka to that in Sudan?
Keep it short and to the point. 3.19. What is the ratio of the Value added (% of GDP) in 1962 in Sri Lanka to that in Sudan?
Keep it short and to the point. 3.25. What is the ratio of the Value added (% of GDP) of 1963 in Sri Lanka to that in Sudan?
Provide a succinct answer. 3.01. What is the ratio of the Value added (% of GDP) in 1960 in Sri Lanka to that in Thailand?
Keep it short and to the point. 1.23. What is the ratio of the Value added (% of GDP) of 1961 in Sri Lanka to that in Thailand?
Your answer should be compact. 1.18. What is the ratio of the Value added (% of GDP) in 1962 in Sri Lanka to that in Thailand?
Provide a succinct answer. 1.11. What is the ratio of the Value added (% of GDP) in 1963 in Sri Lanka to that in Thailand?
Your answer should be compact. 1.1. What is the ratio of the Value added (% of GDP) in 1960 in Sri Lanka to that in Togo?
Your answer should be very brief. 1.99. What is the ratio of the Value added (% of GDP) in 1961 in Sri Lanka to that in Togo?
Your answer should be very brief. 2.37. What is the ratio of the Value added (% of GDP) in 1962 in Sri Lanka to that in Togo?
Keep it short and to the point. 2.82. What is the ratio of the Value added (% of GDP) of 1963 in Sri Lanka to that in Togo?
Provide a succinct answer. 1.62. What is the ratio of the Value added (% of GDP) of 1960 in Sudan to that in Thailand?
Your response must be concise. 0.38. What is the ratio of the Value added (% of GDP) of 1961 in Sudan to that in Thailand?
Your answer should be very brief. 0.37. What is the ratio of the Value added (% of GDP) of 1962 in Sudan to that in Thailand?
Offer a terse response. 0.34. What is the ratio of the Value added (% of GDP) in 1963 in Sudan to that in Thailand?
Offer a terse response. 0.37. What is the ratio of the Value added (% of GDP) of 1960 in Sudan to that in Togo?
Your answer should be very brief. 0.62. What is the ratio of the Value added (% of GDP) in 1961 in Sudan to that in Togo?
Ensure brevity in your answer.  0.74. What is the ratio of the Value added (% of GDP) of 1962 in Sudan to that in Togo?
Your response must be concise. 0.87. What is the ratio of the Value added (% of GDP) of 1963 in Sudan to that in Togo?
Offer a terse response. 0.54. What is the ratio of the Value added (% of GDP) of 1960 in Thailand to that in Togo?
Give a very brief answer. 1.62. What is the ratio of the Value added (% of GDP) of 1961 in Thailand to that in Togo?
Offer a terse response. 2.01. What is the ratio of the Value added (% of GDP) in 1962 in Thailand to that in Togo?
Offer a terse response. 2.53. What is the ratio of the Value added (% of GDP) in 1963 in Thailand to that in Togo?
Offer a terse response. 1.46. What is the difference between the highest and the second highest Value added (% of GDP) of 1960?
Offer a very short reply. 4.52. What is the difference between the highest and the second highest Value added (% of GDP) in 1961?
Provide a succinct answer. 4.2. What is the difference between the highest and the second highest Value added (% of GDP) in 1962?
Your answer should be compact. 4.21. What is the difference between the highest and the second highest Value added (% of GDP) in 1963?
Your answer should be very brief. 3.6. What is the difference between the highest and the lowest Value added (% of GDP) in 1960?
Give a very brief answer. 19.79. What is the difference between the highest and the lowest Value added (% of GDP) in 1961?
Ensure brevity in your answer.  20.05. What is the difference between the highest and the lowest Value added (% of GDP) of 1962?
Offer a terse response. 20.12. What is the difference between the highest and the lowest Value added (% of GDP) in 1963?
Provide a short and direct response. 19.82. 